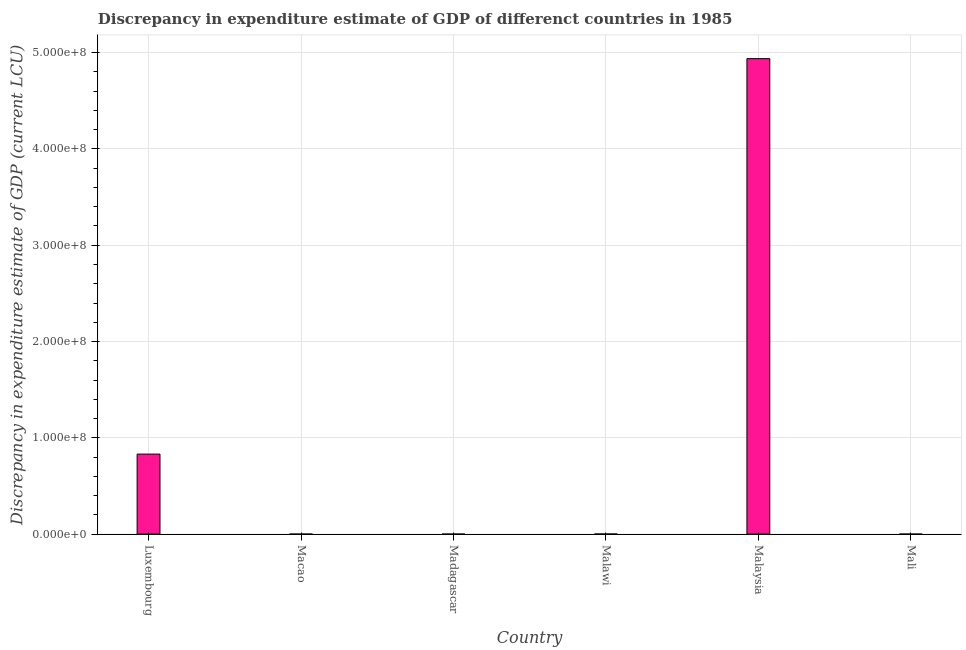Does the graph contain any zero values?
Make the answer very short. Yes. What is the title of the graph?
Keep it short and to the point. Discrepancy in expenditure estimate of GDP of differenct countries in 1985. What is the label or title of the X-axis?
Your answer should be compact. Country. What is the label or title of the Y-axis?
Give a very brief answer. Discrepancy in expenditure estimate of GDP (current LCU). What is the discrepancy in expenditure estimate of gdp in Malaysia?
Keep it short and to the point. 4.94e+08. Across all countries, what is the maximum discrepancy in expenditure estimate of gdp?
Make the answer very short. 4.94e+08. In which country was the discrepancy in expenditure estimate of gdp maximum?
Offer a terse response. Malaysia. What is the sum of the discrepancy in expenditure estimate of gdp?
Offer a very short reply. 5.77e+08. What is the difference between the discrepancy in expenditure estimate of gdp in Luxembourg and Malaysia?
Provide a succinct answer. -4.11e+08. What is the average discrepancy in expenditure estimate of gdp per country?
Give a very brief answer. 9.62e+07. What is the median discrepancy in expenditure estimate of gdp?
Offer a very short reply. 5.00e+04. In how many countries, is the discrepancy in expenditure estimate of gdp greater than 200000000 LCU?
Your answer should be very brief. 1. What is the ratio of the discrepancy in expenditure estimate of gdp in Luxembourg to that in Malaysia?
Make the answer very short. 0.17. Is the discrepancy in expenditure estimate of gdp in Luxembourg less than that in Mali?
Provide a succinct answer. No. What is the difference between the highest and the second highest discrepancy in expenditure estimate of gdp?
Provide a short and direct response. 4.11e+08. What is the difference between the highest and the lowest discrepancy in expenditure estimate of gdp?
Offer a terse response. 4.94e+08. In how many countries, is the discrepancy in expenditure estimate of gdp greater than the average discrepancy in expenditure estimate of gdp taken over all countries?
Your response must be concise. 1. How many countries are there in the graph?
Offer a terse response. 6. What is the Discrepancy in expenditure estimate of GDP (current LCU) in Luxembourg?
Provide a short and direct response. 8.31e+07. What is the Discrepancy in expenditure estimate of GDP (current LCU) of Macao?
Your answer should be very brief. 0. What is the Discrepancy in expenditure estimate of GDP (current LCU) of Madagascar?
Your answer should be very brief. 0. What is the Discrepancy in expenditure estimate of GDP (current LCU) of Malawi?
Offer a terse response. 1.00e+05. What is the Discrepancy in expenditure estimate of GDP (current LCU) in Malaysia?
Your answer should be very brief. 4.94e+08. What is the Discrepancy in expenditure estimate of GDP (current LCU) of Mali?
Ensure brevity in your answer.  0. What is the difference between the Discrepancy in expenditure estimate of GDP (current LCU) in Luxembourg and Malawi?
Keep it short and to the point. 8.30e+07. What is the difference between the Discrepancy in expenditure estimate of GDP (current LCU) in Luxembourg and Malaysia?
Give a very brief answer. -4.11e+08. What is the difference between the Discrepancy in expenditure estimate of GDP (current LCU) in Luxembourg and Mali?
Your answer should be compact. 8.31e+07. What is the difference between the Discrepancy in expenditure estimate of GDP (current LCU) in Malawi and Malaysia?
Offer a terse response. -4.94e+08. What is the difference between the Discrepancy in expenditure estimate of GDP (current LCU) in Malawi and Mali?
Keep it short and to the point. 1.00e+05. What is the difference between the Discrepancy in expenditure estimate of GDP (current LCU) in Malaysia and Mali?
Make the answer very short. 4.94e+08. What is the ratio of the Discrepancy in expenditure estimate of GDP (current LCU) in Luxembourg to that in Malawi?
Your answer should be compact. 830.89. What is the ratio of the Discrepancy in expenditure estimate of GDP (current LCU) in Luxembourg to that in Malaysia?
Offer a terse response. 0.17. What is the ratio of the Discrepancy in expenditure estimate of GDP (current LCU) in Luxembourg to that in Mali?
Provide a succinct answer. 1.29e+11. What is the ratio of the Discrepancy in expenditure estimate of GDP (current LCU) in Malawi to that in Malaysia?
Your answer should be very brief. 0. What is the ratio of the Discrepancy in expenditure estimate of GDP (current LCU) in Malawi to that in Mali?
Offer a very short reply. 1.55e+08. What is the ratio of the Discrepancy in expenditure estimate of GDP (current LCU) in Malaysia to that in Mali?
Your answer should be very brief. 7.64e+11. 